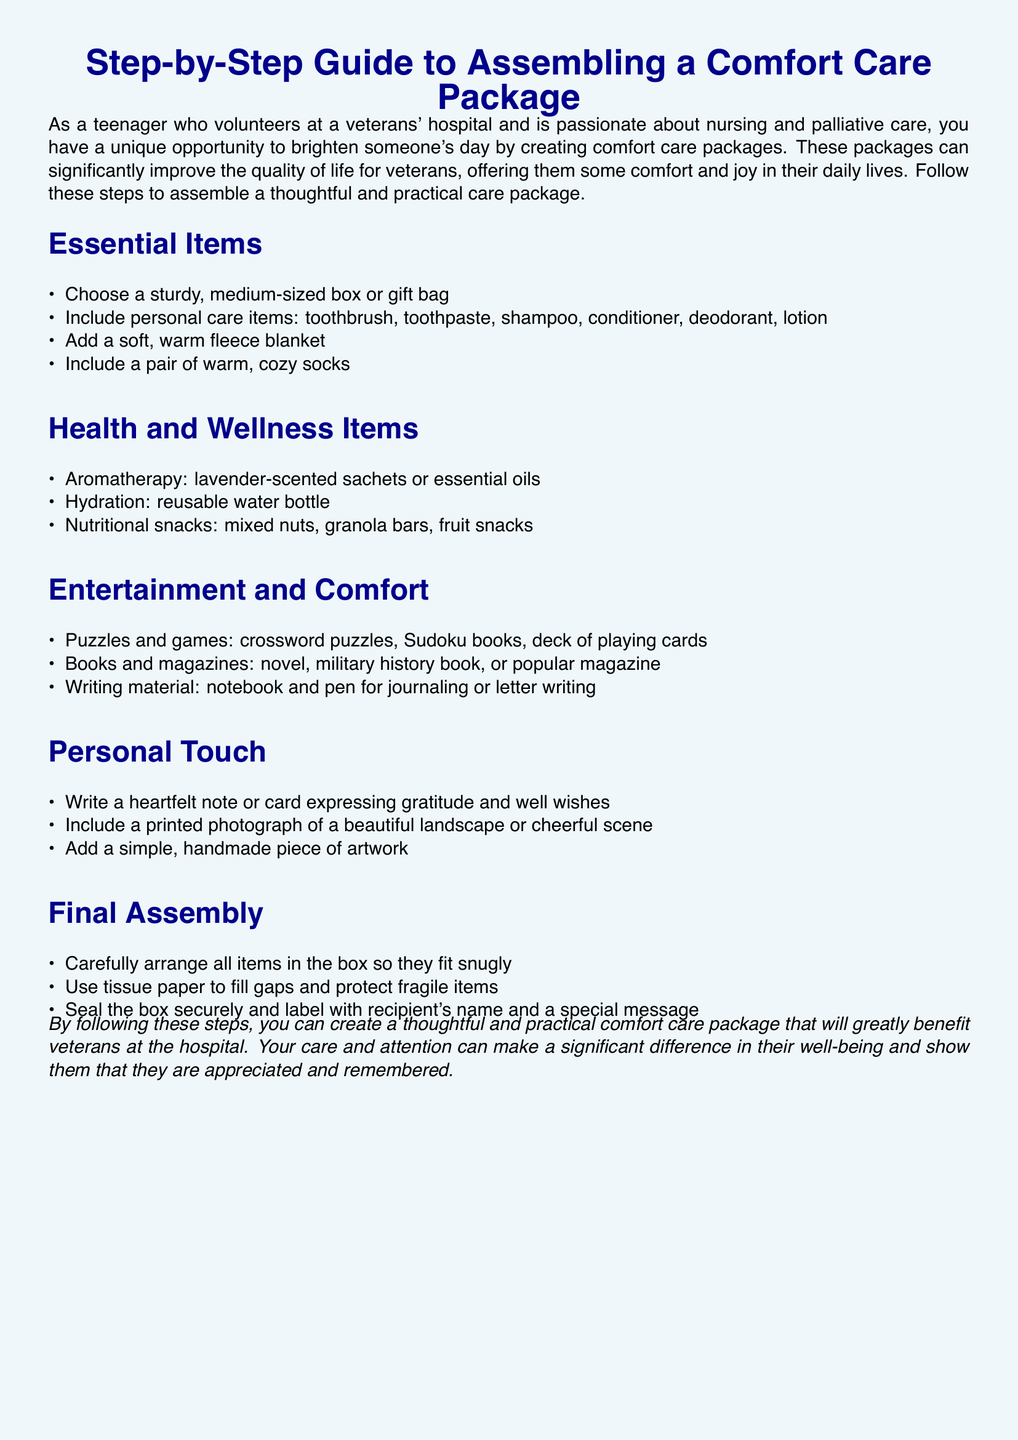What items are included in the essential items section? The essential items section lists personal care items, a blanket, and cozy socks.
Answer: personal care items, fleece blanket, warm socks How many health and wellness items are suggested? The health and wellness section has three listed items: aromatherapy, hydration, and nutritional snacks.
Answer: three What type of books are suggested in the entertainment section? The entertainment section specifies novels and military history books as options.
Answer: novels, military history book What is one personal touch suggested for the care package? The document offers a heartfelt note or card as a personal touch.
Answer: heartfelt note or card What should you use to fill gaps in the box during assembly? The final assembly section recommends using tissue paper to fill gaps.
Answer: tissue paper 